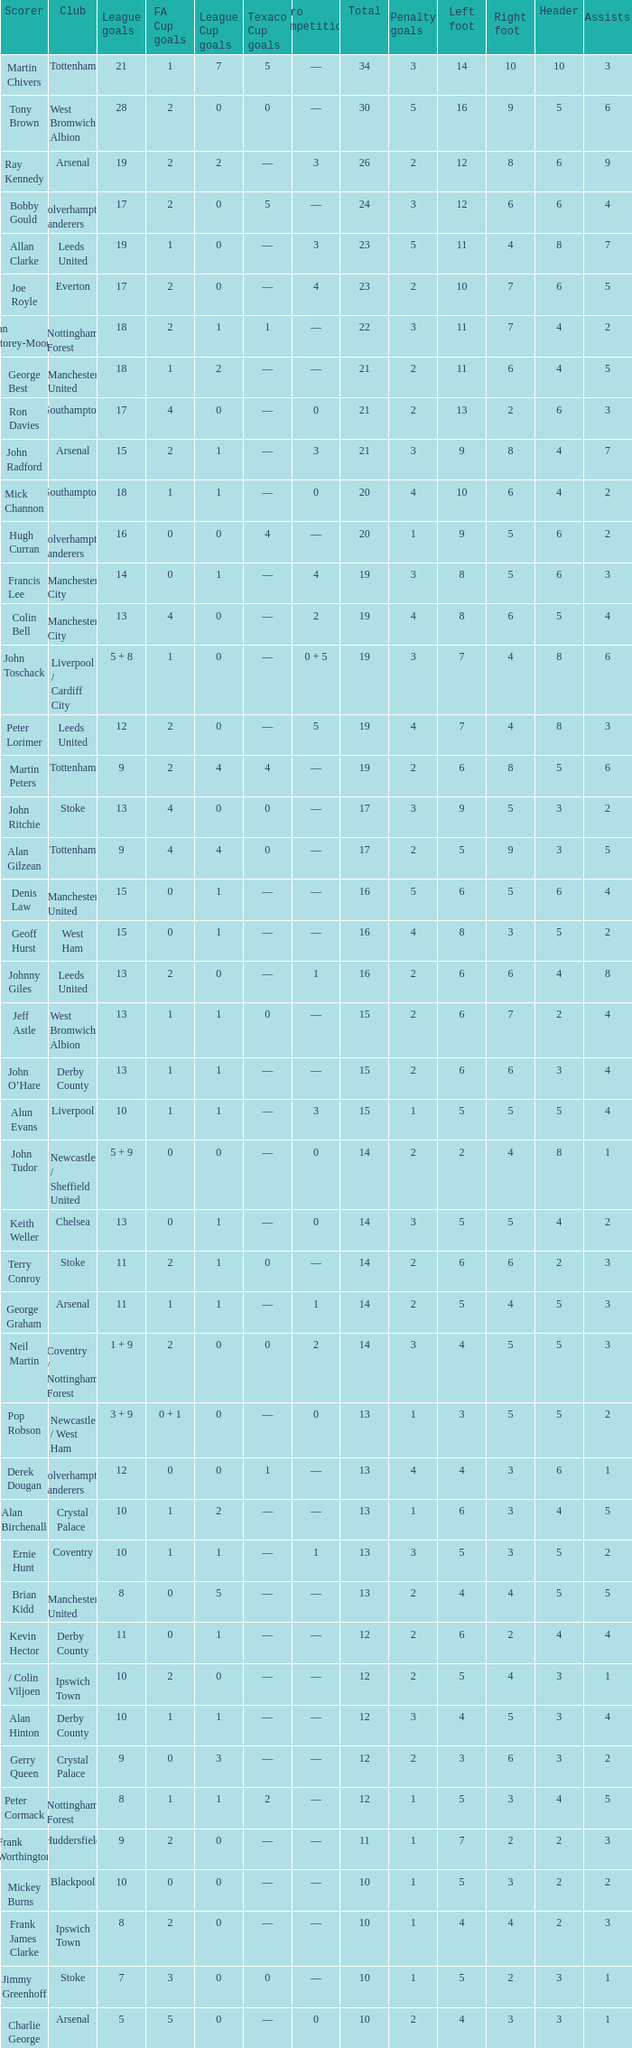What is the average Total, when FA Cup Goals is 1, when League Goals is 10, and when Club is Crystal Palace? 13.0. 